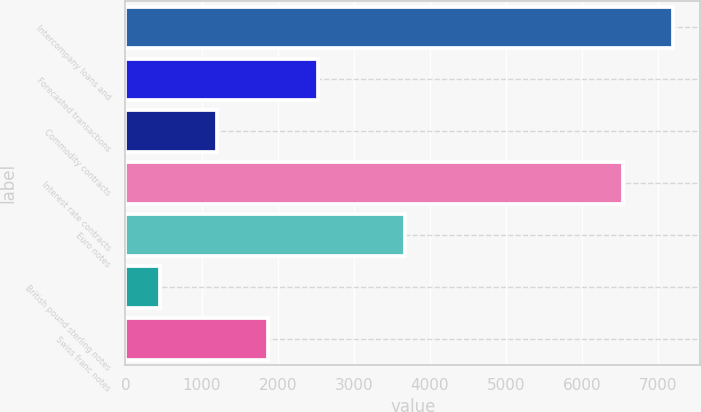<chart> <loc_0><loc_0><loc_500><loc_500><bar_chart><fcel>Intercompany loans and<fcel>Forecasted transactions<fcel>Commodity contracts<fcel>Interest rate contracts<fcel>Euro notes<fcel>British pound sterling notes<fcel>Swiss franc notes<nl><fcel>7195<fcel>2530<fcel>1204<fcel>6532<fcel>3679<fcel>459<fcel>1867<nl></chart> 